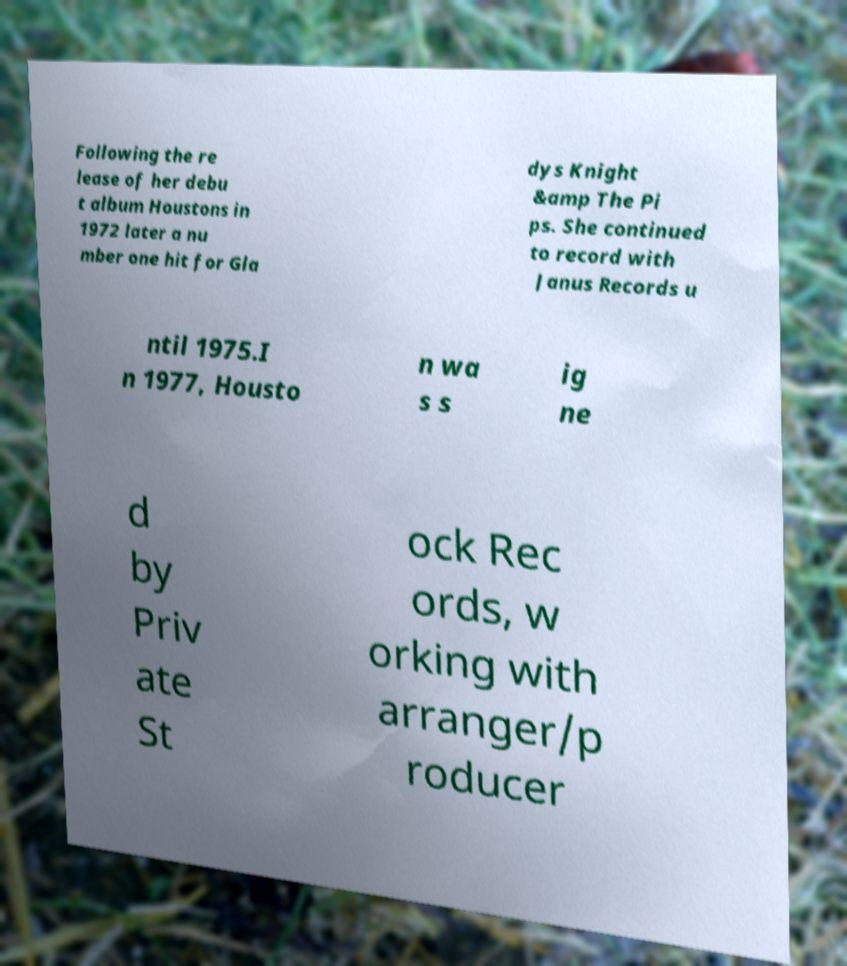For documentation purposes, I need the text within this image transcribed. Could you provide that? Following the re lease of her debu t album Houstons in 1972 later a nu mber one hit for Gla dys Knight &amp The Pi ps. She continued to record with Janus Records u ntil 1975.I n 1977, Housto n wa s s ig ne d by Priv ate St ock Rec ords, w orking with arranger/p roducer 